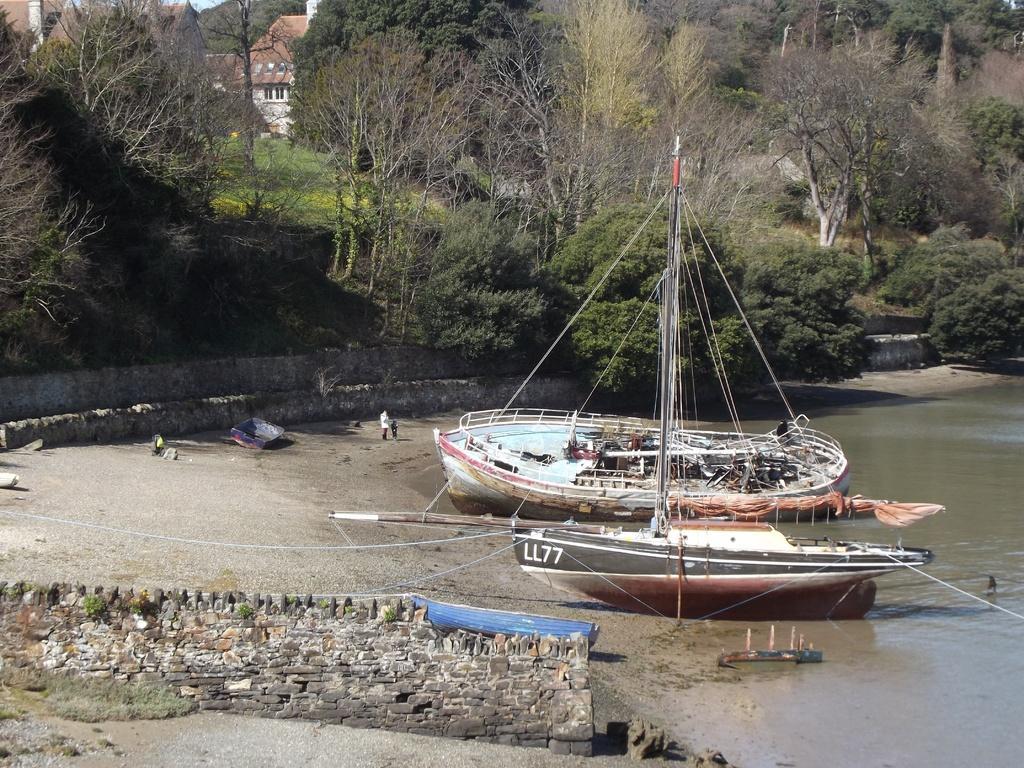Describe this image in one or two sentences. In this image we can see wall, water, there are some persons and ships and in the background of the image there are some trees and houses. 